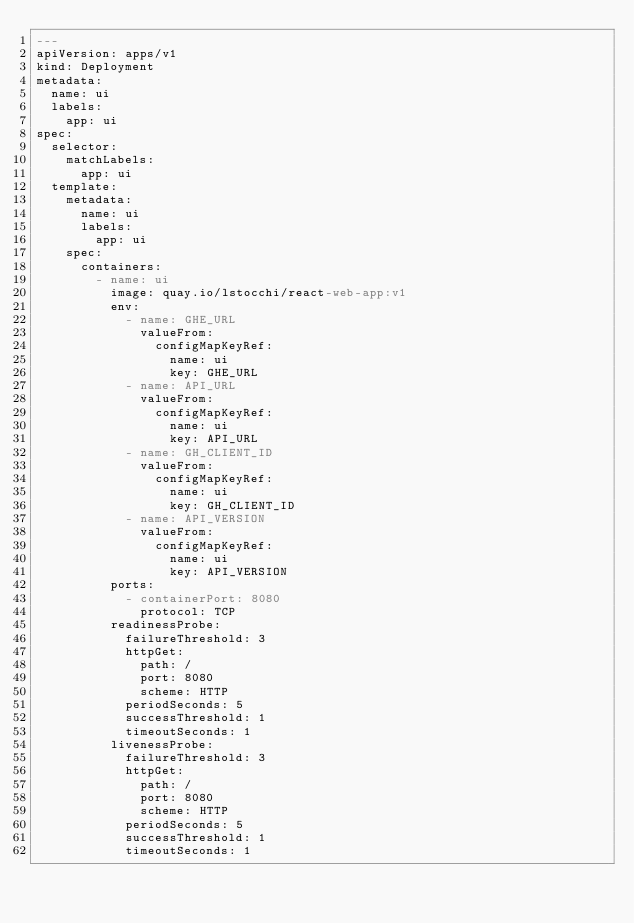<code> <loc_0><loc_0><loc_500><loc_500><_YAML_>---
apiVersion: apps/v1
kind: Deployment
metadata:
  name: ui
  labels:
    app: ui
spec:
  selector:
    matchLabels:
      app: ui
  template:
    metadata:
      name: ui
      labels:
        app: ui
    spec:
      containers:
        - name: ui
          image: quay.io/lstocchi/react-web-app:v1
          env:
            - name: GHE_URL
              valueFrom:
                configMapKeyRef:
                  name: ui
                  key: GHE_URL
            - name: API_URL
              valueFrom:
                configMapKeyRef:
                  name: ui
                  key: API_URL
            - name: GH_CLIENT_ID
              valueFrom:
                configMapKeyRef:
                  name: ui
                  key: GH_CLIENT_ID
            - name: API_VERSION
              valueFrom:
                configMapKeyRef:
                  name: ui
                  key: API_VERSION
          ports:
            - containerPort: 8080
              protocol: TCP
          readinessProbe:
            failureThreshold: 3
            httpGet:
              path: /
              port: 8080
              scheme: HTTP
            periodSeconds: 5
            successThreshold: 1
            timeoutSeconds: 1
          livenessProbe:
            failureThreshold: 3
            httpGet:
              path: /
              port: 8080
              scheme: HTTP
            periodSeconds: 5
            successThreshold: 1
            timeoutSeconds: 1
</code> 